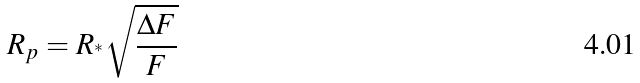Convert formula to latex. <formula><loc_0><loc_0><loc_500><loc_500>R _ { p } = R _ { ^ { * } } \sqrt { \frac { \Delta F } { F } }</formula> 